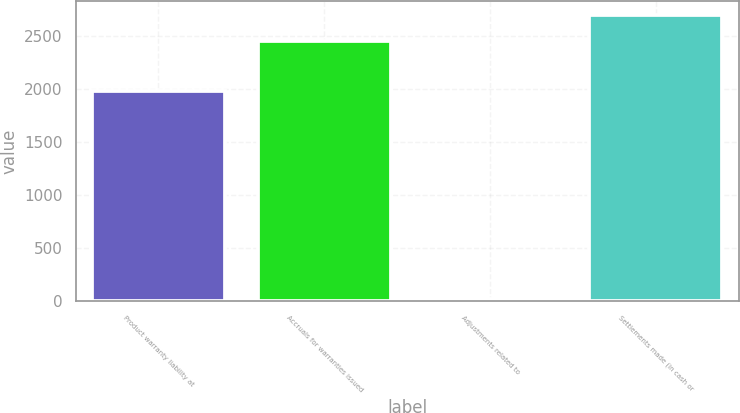<chart> <loc_0><loc_0><loc_500><loc_500><bar_chart><fcel>Product warranty liability at<fcel>Accruals for warranties issued<fcel>Adjustments related to<fcel>Settlements made (in cash or<nl><fcel>1987<fcel>2460.8<fcel>17<fcel>2697.7<nl></chart> 